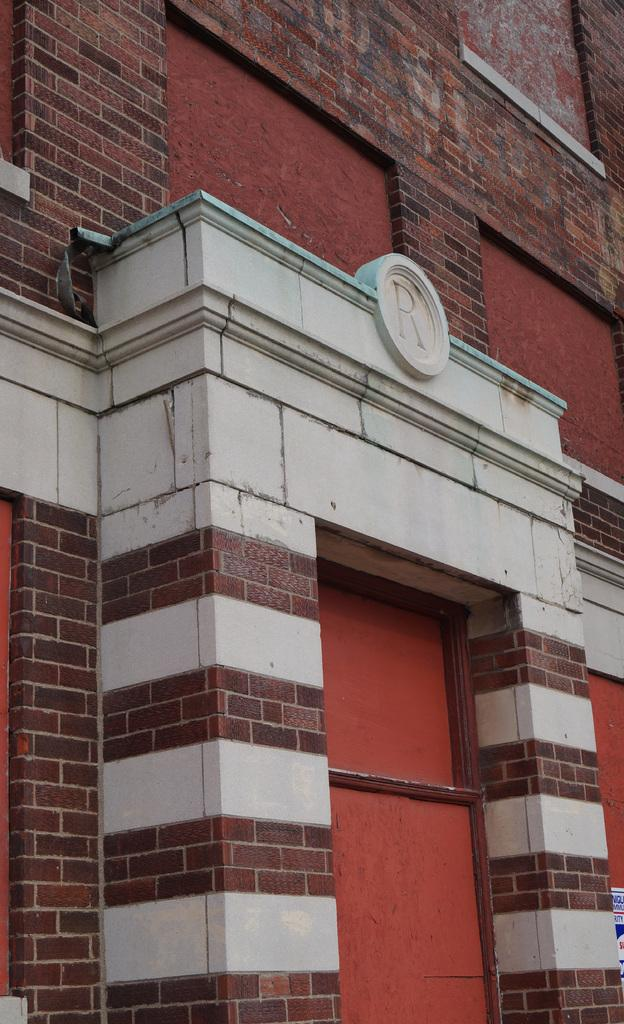What type of structure is depicted in the image? The image is a picture of an arc of a building. Can you describe the shape of the building in the image? The building has an arc shape. How does the wind affect the size of the building in the image? The image does not show any wind, and the size of the building is not affected by wind. 